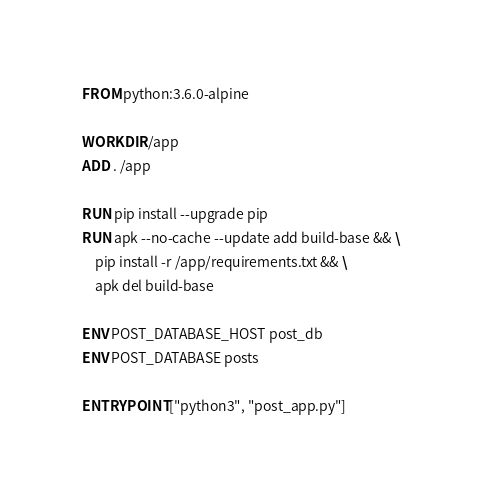<code> <loc_0><loc_0><loc_500><loc_500><_Dockerfile_>FROM python:3.6.0-alpine

WORKDIR /app
ADD . /app

RUN pip install --upgrade pip
RUN apk --no-cache --update add build-base && \
    pip install -r /app/requirements.txt && \
    apk del build-base

ENV POST_DATABASE_HOST post_db
ENV POST_DATABASE posts

ENTRYPOINT ["python3", "post_app.py"]
</code> 